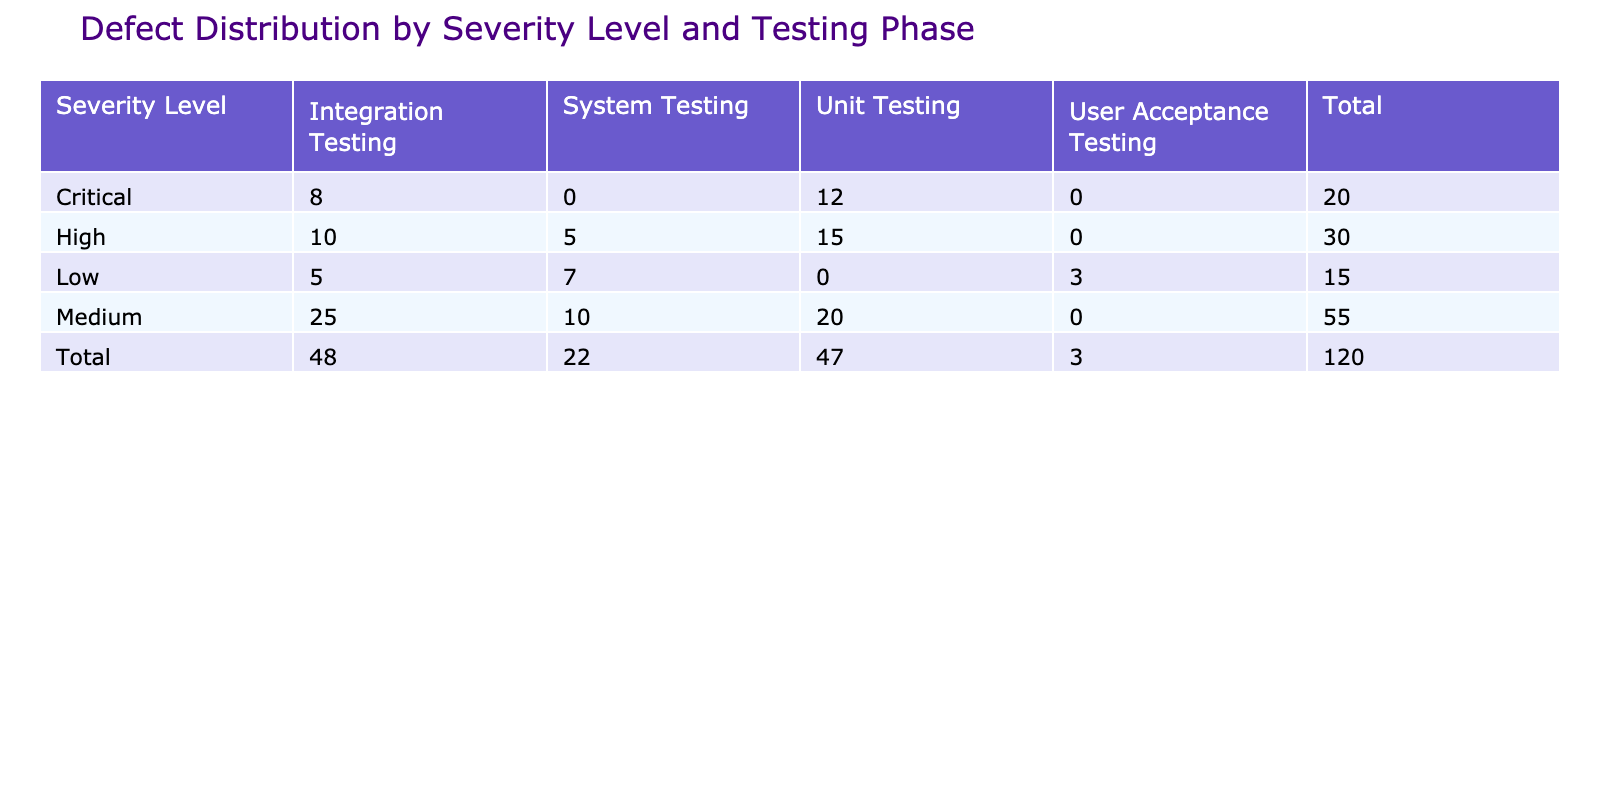What is the total number of critical defects across all testing phases? The number of critical defects is given in the table. We add the values for Critical across all testing phases: Unit Testing (12) + Integration Testing (8) = 20.
Answer: 20 Which testing phase has the highest number of medium defects? By examining the table, we see the number of medium defects in each testing phase: Unit Testing (20), Integration Testing (25), and System Testing (10). The highest is 25 in Integration Testing.
Answer: Integration Testing True or False: There are no defects classified as low severity during the Unit Testing phase. Referring to the table, there are no entries for Low severity in the Unit Testing phase, confirming that this statement is true.
Answer: True What is the average number of high defects across all testing phases? To find the average, we first sum the number of high defects: Unit Testing (15) + Integration Testing (10) + System Testing (5) = 30. There are three testing phases, so we calculate the average: 30 / 3 = 10.
Answer: 10 Which severity level has the least number of defects in the Integration Testing phase? Looking at the Integration Testing column, we find the values for each severity level: Critical (8), High (10), Medium (25), and Low (5). The least is 5 for Low severity.
Answer: Low How many total defects are there in the User Acceptance Testing phase? The table shows only one entry for User Acceptance Testing, which is 3 defects classified as Low severity. Thus, the total is directly taken from this entry.
Answer: 3 What is the difference between the total number of medium and high defects across all testing phases? First, sum the medium defects: 20 (Unit Testing) + 25 (Integration Testing) + 10 (System Testing) = 55. Next, sum the high defects: 15 (Unit Testing) + 10 (Integration Testing) + 5 (System Testing) = 30. The difference is 55 - 30 = 25.
Answer: 25 Is the sum of defects from Unit Testing greater than the sum from System Testing? From the table, the total defects for Unit Testing are: Critical (12) + High (15) + Medium (20) = 47. For System Testing: High (5) + Medium (10) + Low (7) = 22. Since 47 > 22, the answer is true.
Answer: True How many defects are categorized as High severity in total? The total number of defects categorized as High severity includes: Unit Testing (15), Integration Testing (10), and System Testing (5). Summing these values gives 15 + 10 + 5 = 30.
Answer: 30 